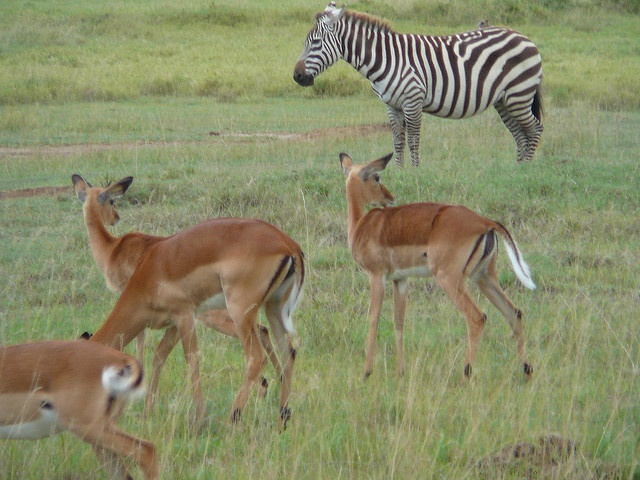Describe the objects in this image and their specific colors. I can see a zebra in olive, gray, darkgray, black, and lightgray tones in this image. 